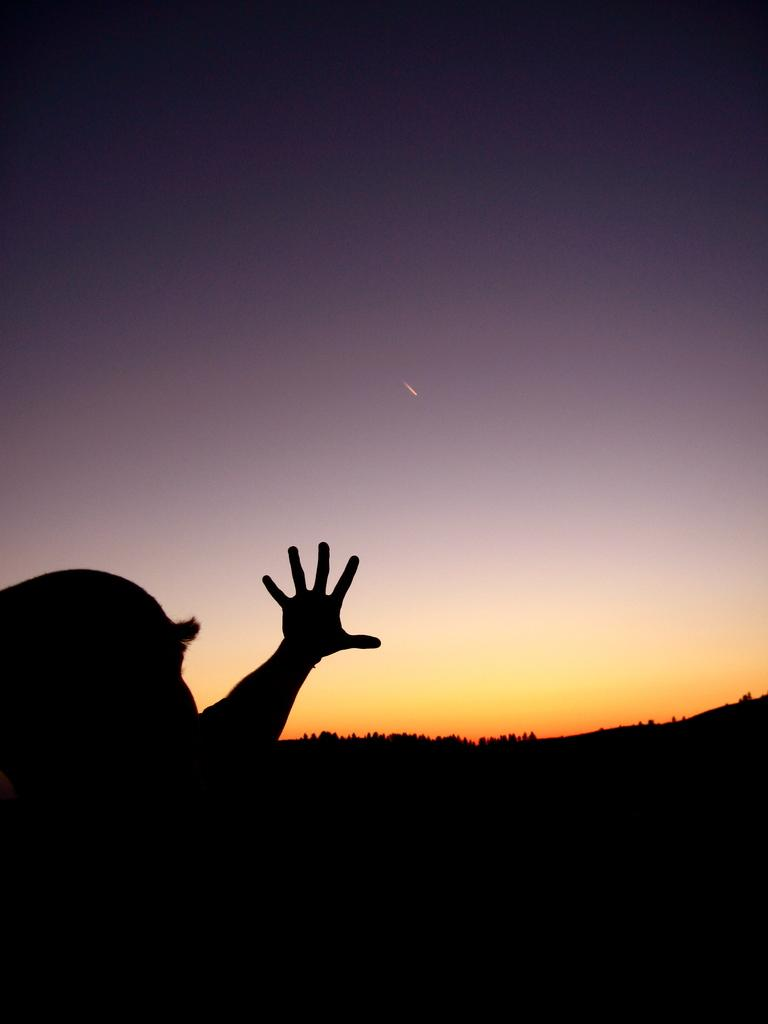What is the main subject of the image? There is a person in the image. What can be seen in the background of the image? There are trees and the sky visible in the background of the image. How many scarecrows are standing at the edge of the field in the image? There are no scarecrows or fields present in the image. What is the rate of the person's movement in the image? The image is a still photograph, so there is no movement or rate of movement to measure. 